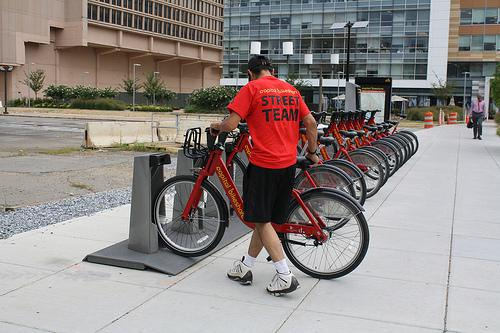Question: how many people in the picture?
Choices:
A. Three.
B. Two.
C. Four.
D. Five.
Answer with the letter. Answer: B Question: what gender are the people in the photo?
Choices:
A. Male.
B. Female.
C. Woman.
D. Trans.
Answer with the letter. Answer: A Question: what color is the man's t-shirt?
Choices:
A. Black.
B. Pink.
C. Green.
D. Red.
Answer with the letter. Answer: D Question: what color are the bikes?
Choices:
A. Black.
B. White.
C. Orange.
D. Red.
Answer with the letter. Answer: D Question: who is holding a bike?
Choices:
A. The girl.
B. The teen.
C. Man.
D. The woman.
Answer with the letter. Answer: C Question: where is the photo being taken?
Choices:
A. At a fair.
B. At a race.
C. At a bike post.
D. At a family dinner.
Answer with the letter. Answer: C Question: what is the man holding?
Choices:
A. Bike.
B. A kite.
C. A motorcycle.
D. A hammer.
Answer with the letter. Answer: A Question: what time of day was the picture taken?
Choices:
A. Morning.
B. Evening.
C. Daytime.
D. Sunrise.
Answer with the letter. Answer: C 